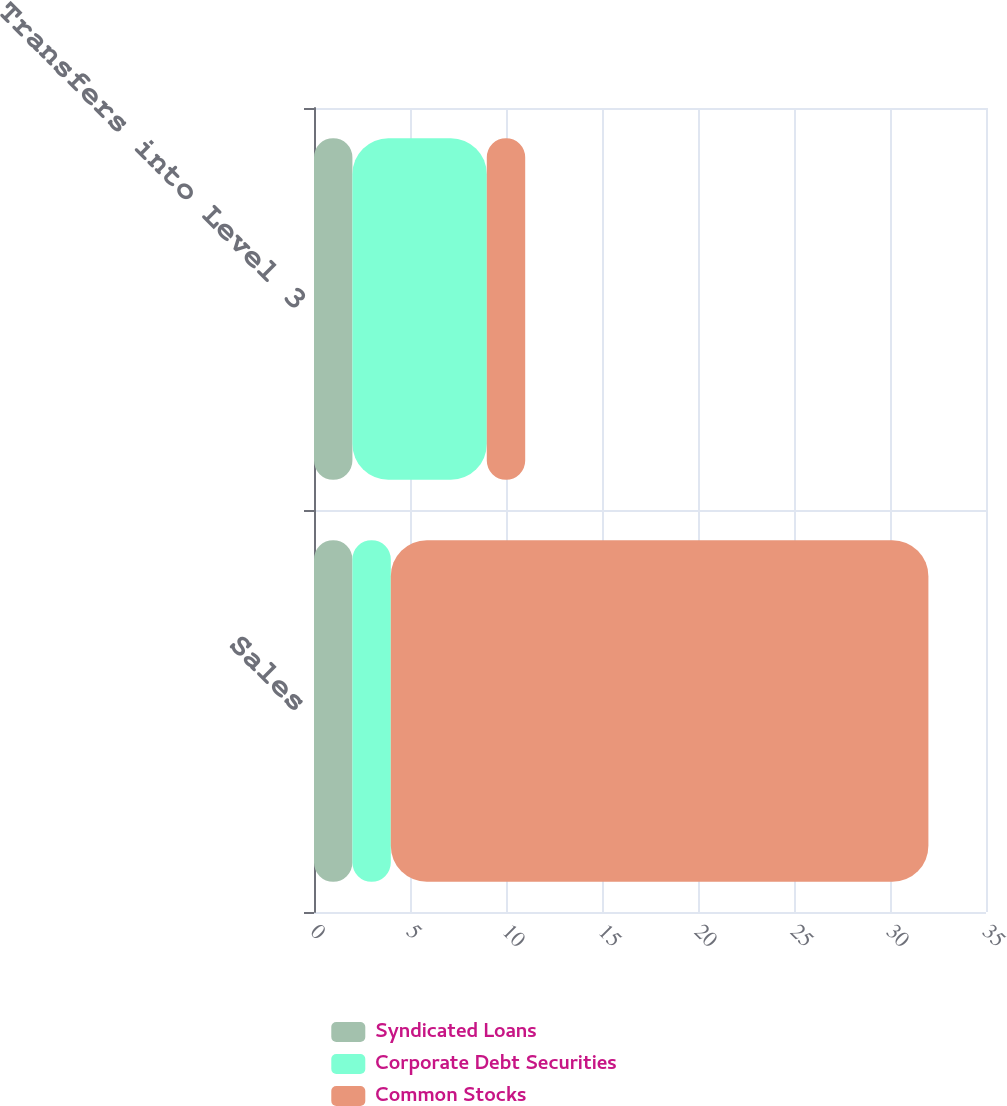<chart> <loc_0><loc_0><loc_500><loc_500><stacked_bar_chart><ecel><fcel>Sales<fcel>Transfers into Level 3<nl><fcel>Syndicated Loans<fcel>2<fcel>2<nl><fcel>Corporate Debt Securities<fcel>2<fcel>7<nl><fcel>Common Stocks<fcel>28<fcel>2<nl></chart> 